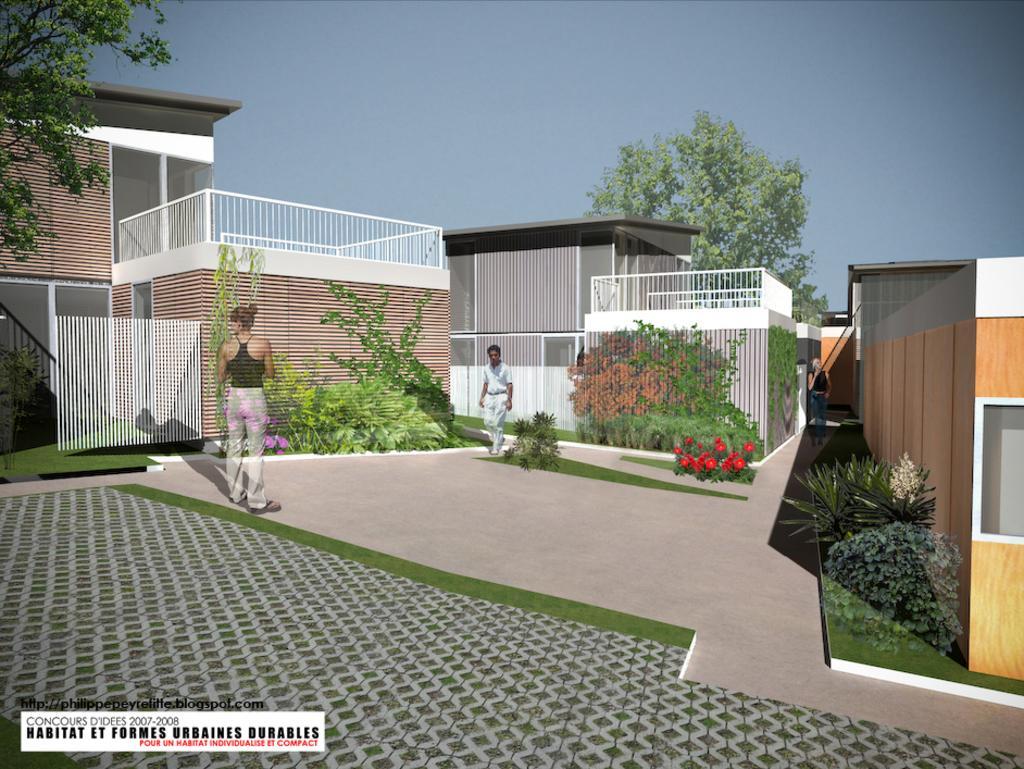Please provide a concise description of this image. The image is looking like an animated image. In the center of the picture there are buildings, trees, plants, grass, flowers, people and other objects. In the foreground it is pavement. At the top it is sky. 